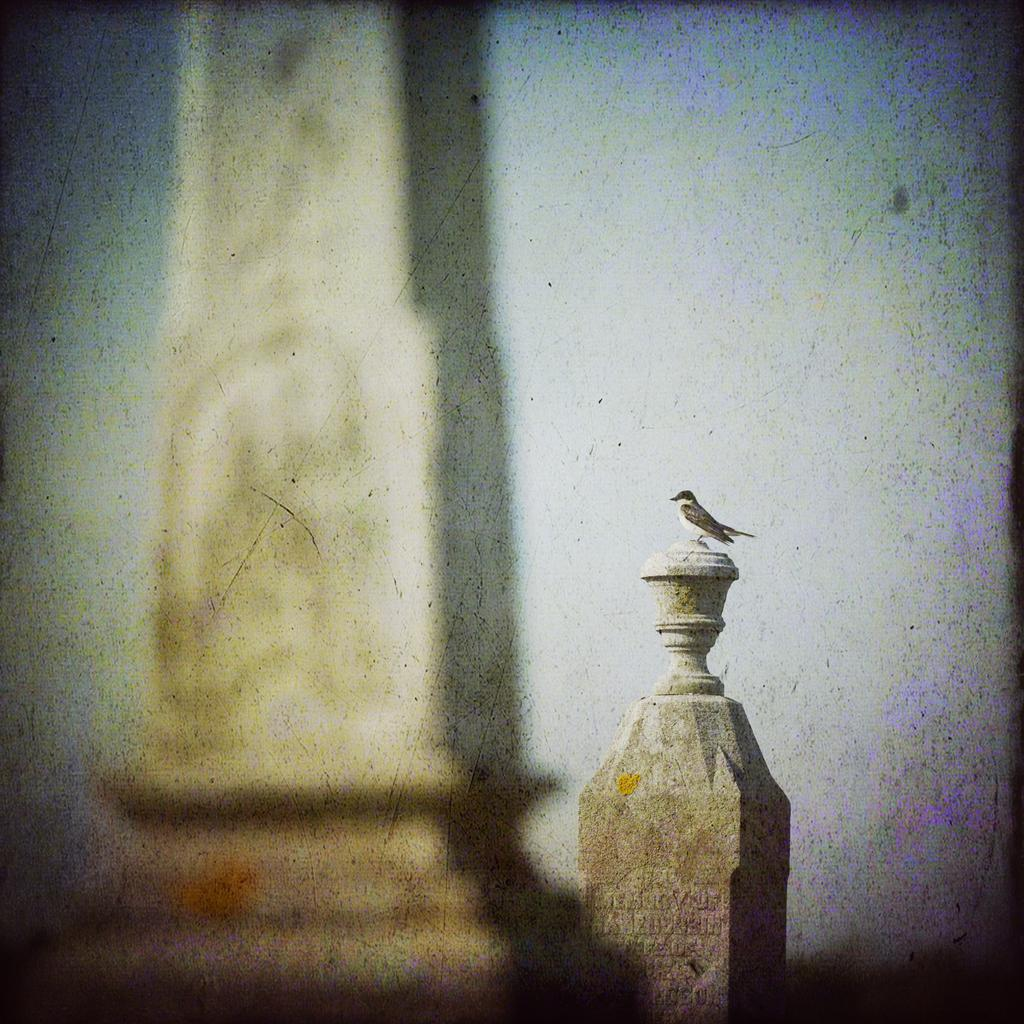What structures can be seen in the image? There are two pillars in the image. What type of animal is present in the image? There is a bird in the image. What color is the bird in the image? The bird is in black and white color. What is the color of the background in the image? The background of the image is white. What type of straw can be seen in the image? There is no straw present in the image. What scent is associated with the bird in the image? The image does not provide any information about the scent of the bird. 